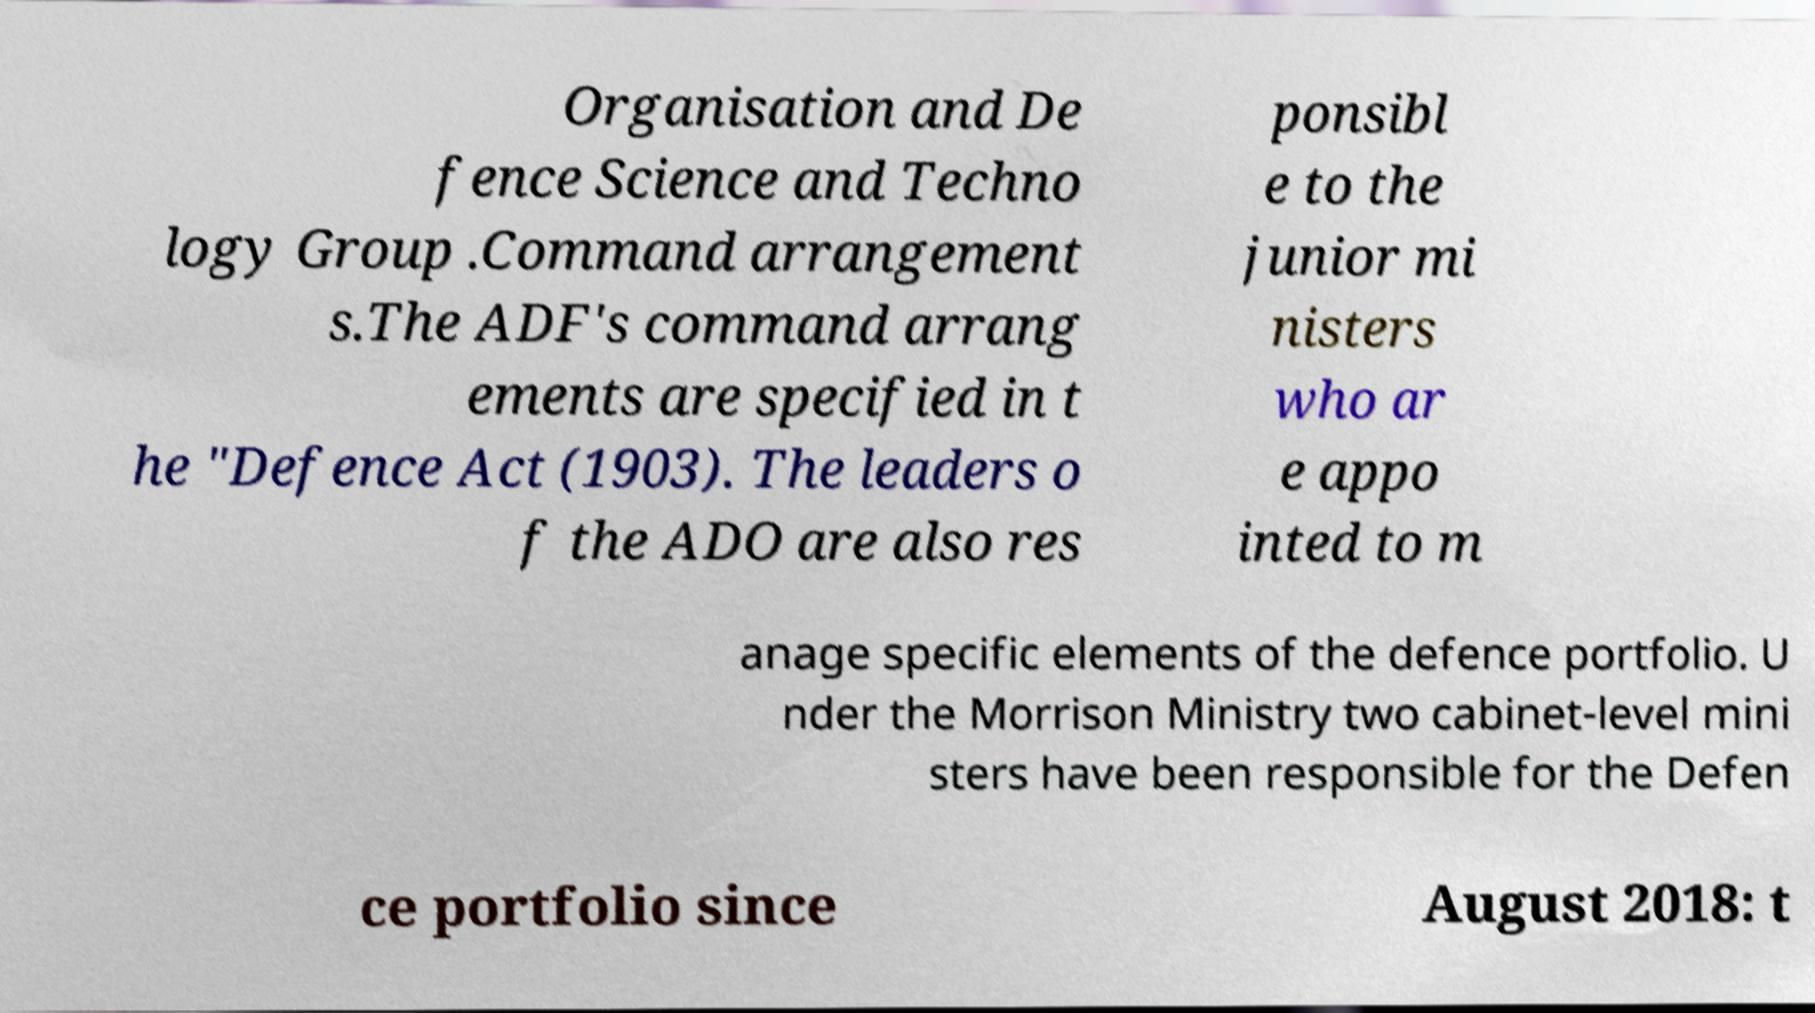There's text embedded in this image that I need extracted. Can you transcribe it verbatim? Organisation and De fence Science and Techno logy Group .Command arrangement s.The ADF's command arrang ements are specified in t he "Defence Act (1903). The leaders o f the ADO are also res ponsibl e to the junior mi nisters who ar e appo inted to m anage specific elements of the defence portfolio. U nder the Morrison Ministry two cabinet-level mini sters have been responsible for the Defen ce portfolio since August 2018: t 